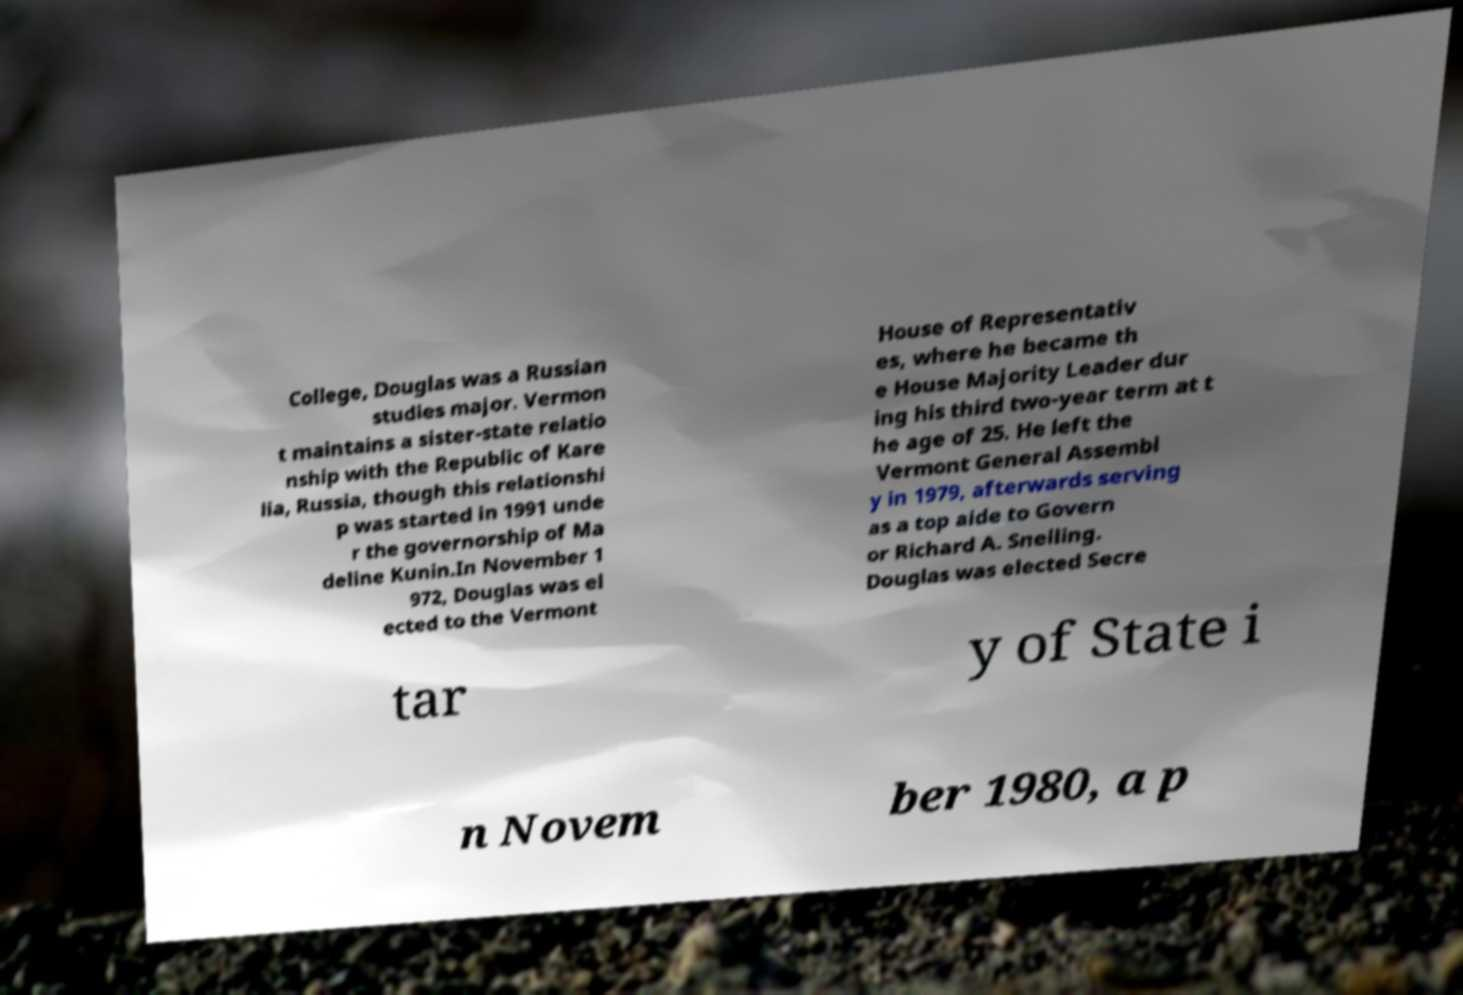Could you assist in decoding the text presented in this image and type it out clearly? College, Douglas was a Russian studies major. Vermon t maintains a sister-state relatio nship with the Republic of Kare lia, Russia, though this relationshi p was started in 1991 unde r the governorship of Ma deline Kunin.In November 1 972, Douglas was el ected to the Vermont House of Representativ es, where he became th e House Majority Leader dur ing his third two-year term at t he age of 25. He left the Vermont General Assembl y in 1979, afterwards serving as a top aide to Govern or Richard A. Snelling. Douglas was elected Secre tar y of State i n Novem ber 1980, a p 